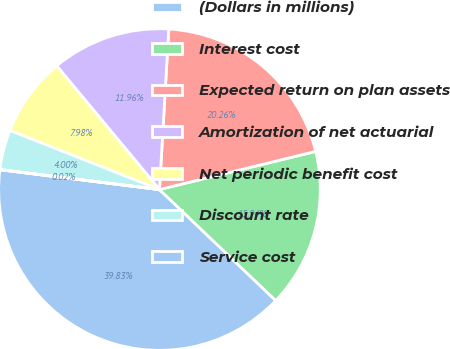<chart> <loc_0><loc_0><loc_500><loc_500><pie_chart><fcel>(Dollars in millions)<fcel>Interest cost<fcel>Expected return on plan assets<fcel>Amortization of net actuarial<fcel>Net periodic benefit cost<fcel>Discount rate<fcel>Service cost<nl><fcel>39.83%<fcel>15.94%<fcel>20.26%<fcel>11.96%<fcel>7.98%<fcel>4.0%<fcel>0.02%<nl></chart> 